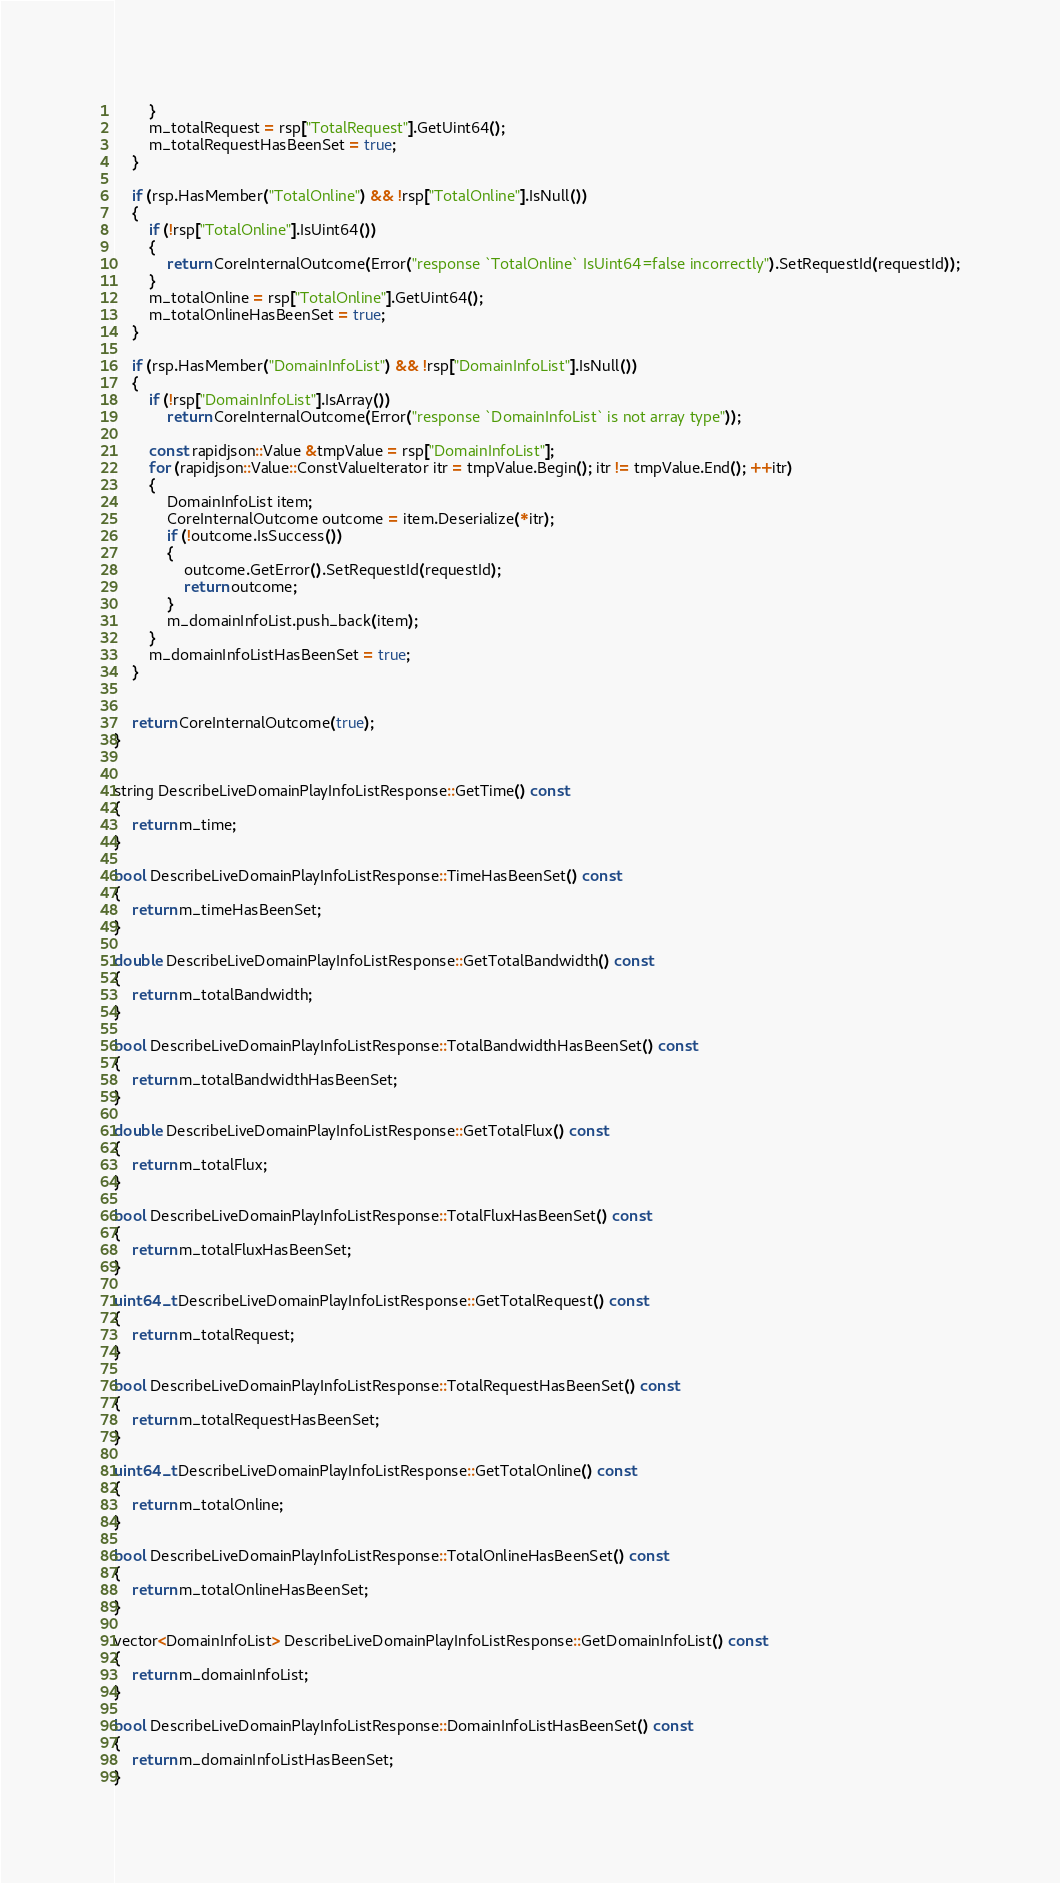Convert code to text. <code><loc_0><loc_0><loc_500><loc_500><_C++_>        }
        m_totalRequest = rsp["TotalRequest"].GetUint64();
        m_totalRequestHasBeenSet = true;
    }

    if (rsp.HasMember("TotalOnline") && !rsp["TotalOnline"].IsNull())
    {
        if (!rsp["TotalOnline"].IsUint64())
        {
            return CoreInternalOutcome(Error("response `TotalOnline` IsUint64=false incorrectly").SetRequestId(requestId));
        }
        m_totalOnline = rsp["TotalOnline"].GetUint64();
        m_totalOnlineHasBeenSet = true;
    }

    if (rsp.HasMember("DomainInfoList") && !rsp["DomainInfoList"].IsNull())
    {
        if (!rsp["DomainInfoList"].IsArray())
            return CoreInternalOutcome(Error("response `DomainInfoList` is not array type"));

        const rapidjson::Value &tmpValue = rsp["DomainInfoList"];
        for (rapidjson::Value::ConstValueIterator itr = tmpValue.Begin(); itr != tmpValue.End(); ++itr)
        {
            DomainInfoList item;
            CoreInternalOutcome outcome = item.Deserialize(*itr);
            if (!outcome.IsSuccess())
            {
                outcome.GetError().SetRequestId(requestId);
                return outcome;
            }
            m_domainInfoList.push_back(item);
        }
        m_domainInfoListHasBeenSet = true;
    }


    return CoreInternalOutcome(true);
}


string DescribeLiveDomainPlayInfoListResponse::GetTime() const
{
    return m_time;
}

bool DescribeLiveDomainPlayInfoListResponse::TimeHasBeenSet() const
{
    return m_timeHasBeenSet;
}

double DescribeLiveDomainPlayInfoListResponse::GetTotalBandwidth() const
{
    return m_totalBandwidth;
}

bool DescribeLiveDomainPlayInfoListResponse::TotalBandwidthHasBeenSet() const
{
    return m_totalBandwidthHasBeenSet;
}

double DescribeLiveDomainPlayInfoListResponse::GetTotalFlux() const
{
    return m_totalFlux;
}

bool DescribeLiveDomainPlayInfoListResponse::TotalFluxHasBeenSet() const
{
    return m_totalFluxHasBeenSet;
}

uint64_t DescribeLiveDomainPlayInfoListResponse::GetTotalRequest() const
{
    return m_totalRequest;
}

bool DescribeLiveDomainPlayInfoListResponse::TotalRequestHasBeenSet() const
{
    return m_totalRequestHasBeenSet;
}

uint64_t DescribeLiveDomainPlayInfoListResponse::GetTotalOnline() const
{
    return m_totalOnline;
}

bool DescribeLiveDomainPlayInfoListResponse::TotalOnlineHasBeenSet() const
{
    return m_totalOnlineHasBeenSet;
}

vector<DomainInfoList> DescribeLiveDomainPlayInfoListResponse::GetDomainInfoList() const
{
    return m_domainInfoList;
}

bool DescribeLiveDomainPlayInfoListResponse::DomainInfoListHasBeenSet() const
{
    return m_domainInfoListHasBeenSet;
}


</code> 